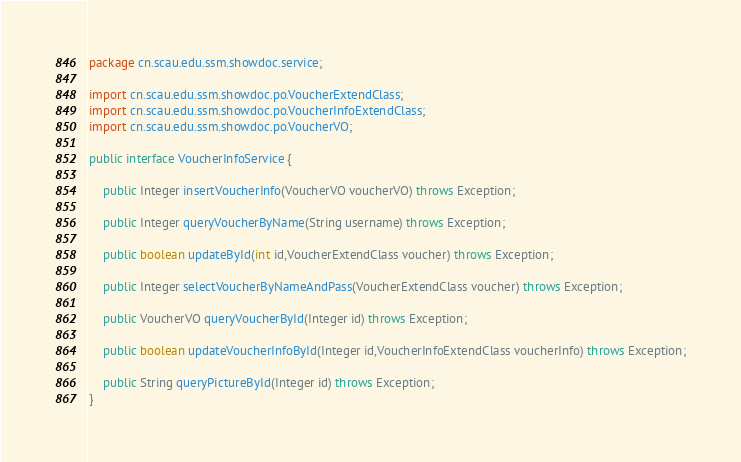<code> <loc_0><loc_0><loc_500><loc_500><_Java_>package cn.scau.edu.ssm.showdoc.service;

import cn.scau.edu.ssm.showdoc.po.VoucherExtendClass;
import cn.scau.edu.ssm.showdoc.po.VoucherInfoExtendClass;
import cn.scau.edu.ssm.showdoc.po.VoucherVO;

public interface VoucherInfoService {
	
	public Integer insertVoucherInfo(VoucherVO voucherVO) throws Exception;
	
	public Integer queryVoucherByName(String username) throws Exception;
	
	public boolean updateById(int id,VoucherExtendClass voucher) throws Exception;
	
	public Integer selectVoucherByNameAndPass(VoucherExtendClass voucher) throws Exception;
	
	public VoucherVO queryVoucherById(Integer id) throws Exception;
	
	public boolean updateVoucherInfoById(Integer id,VoucherInfoExtendClass voucherInfo) throws Exception;
	
	public String queryPictureById(Integer id) throws Exception;
}
</code> 